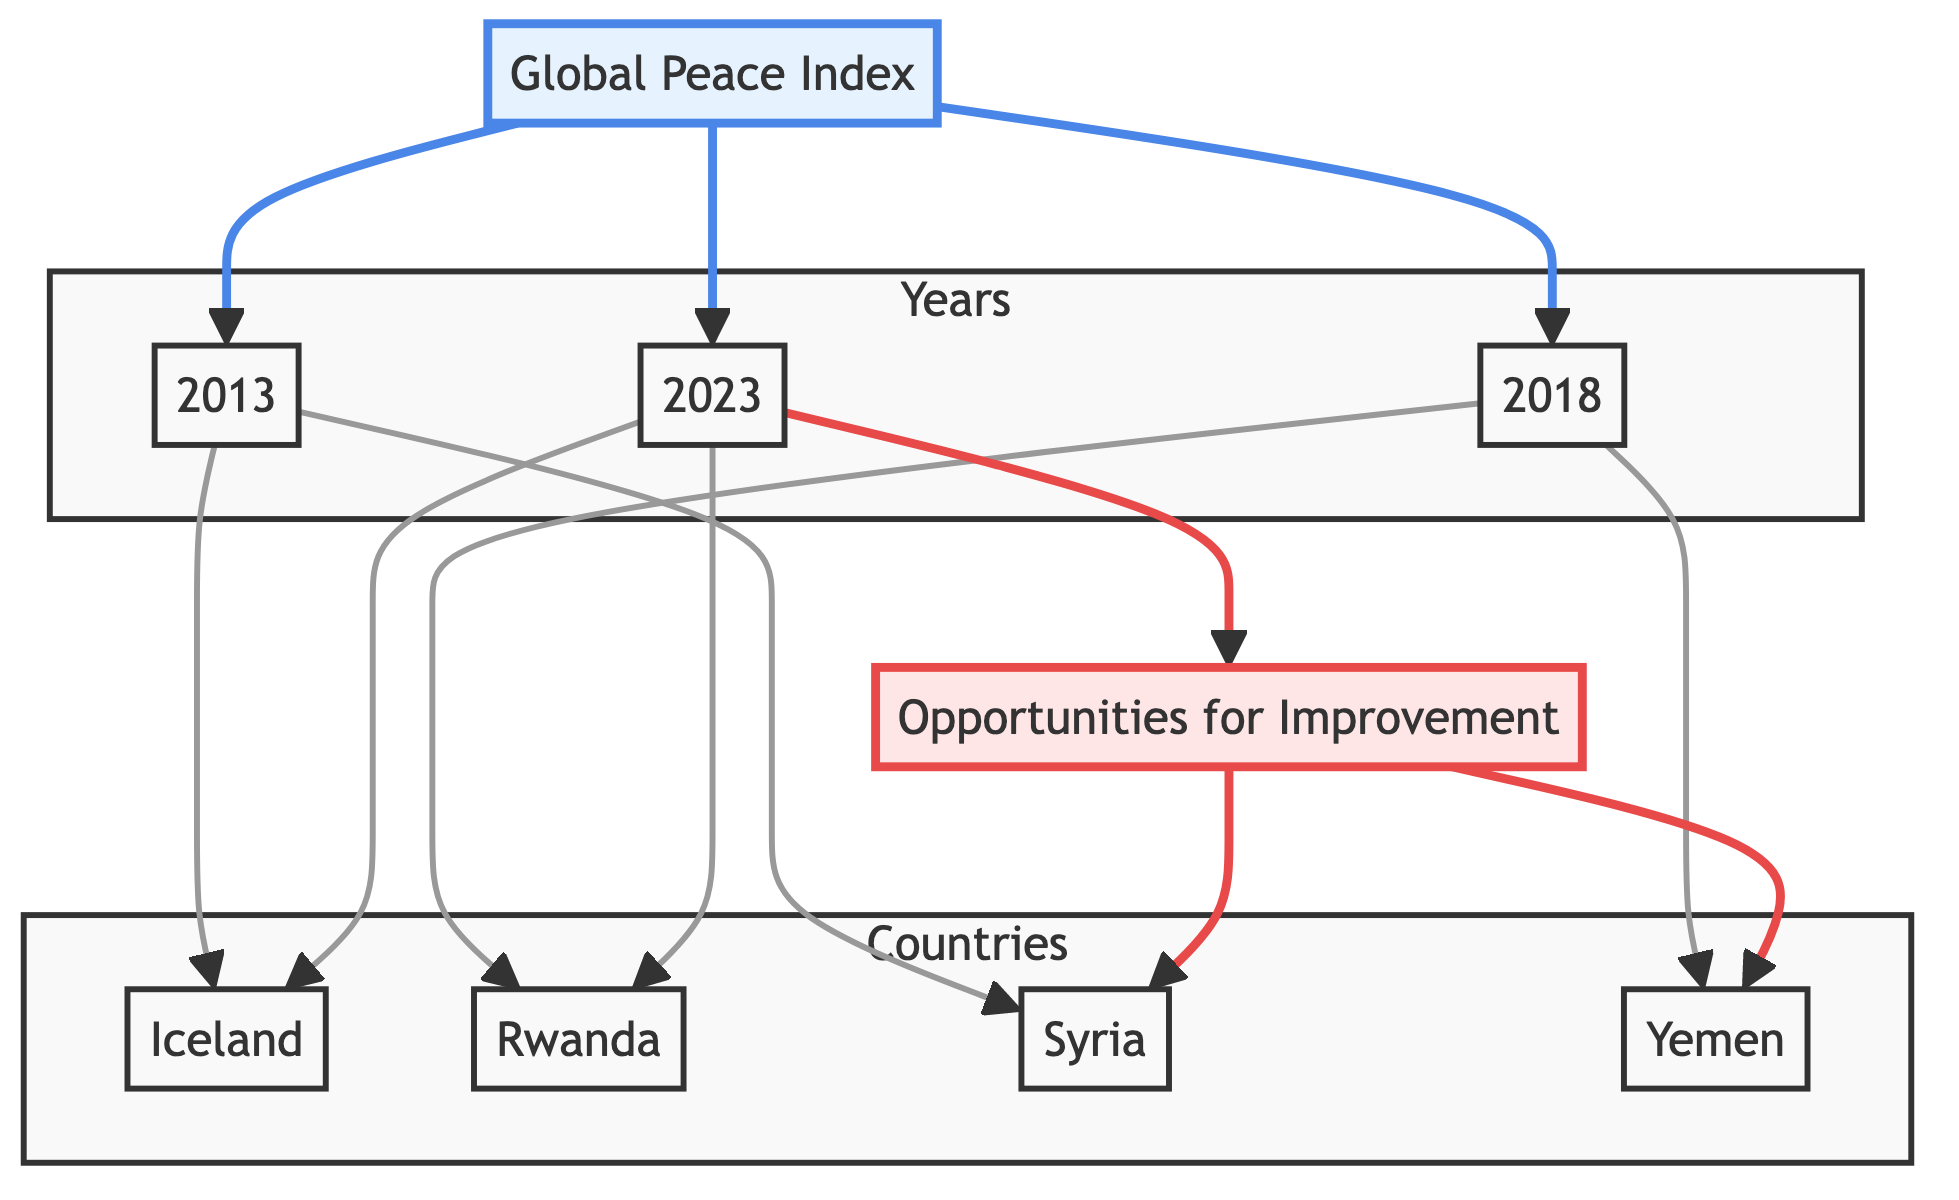What is the first year represented in the Global Peace Index? The diagram shows three years associated with the Global Peace Index: 2013, 2018, and 2023. The first listed year is 2013.
Answer: 2013 Which countries did the Global Peace Index associate with the year 2018? In 2018, the diagram connects the Global Peace Index to two countries: Rwanda and Yemen, shown by the edges linking these nodes.
Answer: Rwanda, Yemen How many nodes are connected to the Opportunities for Improvement node? The Opportunities for Improvement node has two edges leading to it: one connects to Syria and the other to Yemen, indicating that both countries are associated with areas needing improvement.
Answer: 2 Which year shows an improvement by highlighting Rwanda? The diagram shows that Rwanda is linked to both 2018 and 2023, indicating that Rwanda is noted for improvement in peace over these years. Thus, the most recent year showing improvement is 2023.
Answer: 2023 What is the relationship between the Global Peace Index and the year 2023? The Global Peace Index is directly connected to the year 2023 by an edge, indicating that the data for that year falls under the index's assessment.
Answer: Direct connection How many countries were connected to the Global Peace Index in the year 2013? The Global Peace Index is connected to two countries in the year 2013: Iceland and Syria, which are represented by edges leading from that year node.
Answer: 2 Which country appears in both the 2018 and the 2023 assessments of the Global Peace Index? The diagram shows that Rwanda appears in both the year nodes of 2018 and 2023, indicating it is linked to improvements noted across both years.
Answer: Rwanda Which two countries require attention as indicated in the Opportunities for Improvement node? The diagram shows that opportunities for improvement are linked to Syria and Yemen, indicating these two countries require further attention regarding peace.
Answer: Syria, Yemen 